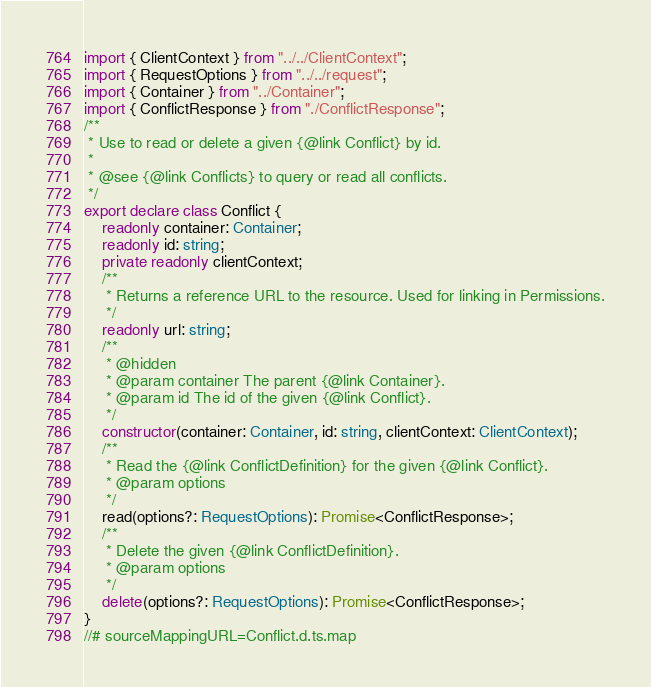<code> <loc_0><loc_0><loc_500><loc_500><_TypeScript_>import { ClientContext } from "../../ClientContext";
import { RequestOptions } from "../../request";
import { Container } from "../Container";
import { ConflictResponse } from "./ConflictResponse";
/**
 * Use to read or delete a given {@link Conflict} by id.
 *
 * @see {@link Conflicts} to query or read all conflicts.
 */
export declare class Conflict {
    readonly container: Container;
    readonly id: string;
    private readonly clientContext;
    /**
     * Returns a reference URL to the resource. Used for linking in Permissions.
     */
    readonly url: string;
    /**
     * @hidden
     * @param container The parent {@link Container}.
     * @param id The id of the given {@link Conflict}.
     */
    constructor(container: Container, id: string, clientContext: ClientContext);
    /**
     * Read the {@link ConflictDefinition} for the given {@link Conflict}.
     * @param options
     */
    read(options?: RequestOptions): Promise<ConflictResponse>;
    /**
     * Delete the given {@link ConflictDefinition}.
     * @param options
     */
    delete(options?: RequestOptions): Promise<ConflictResponse>;
}
//# sourceMappingURL=Conflict.d.ts.map</code> 